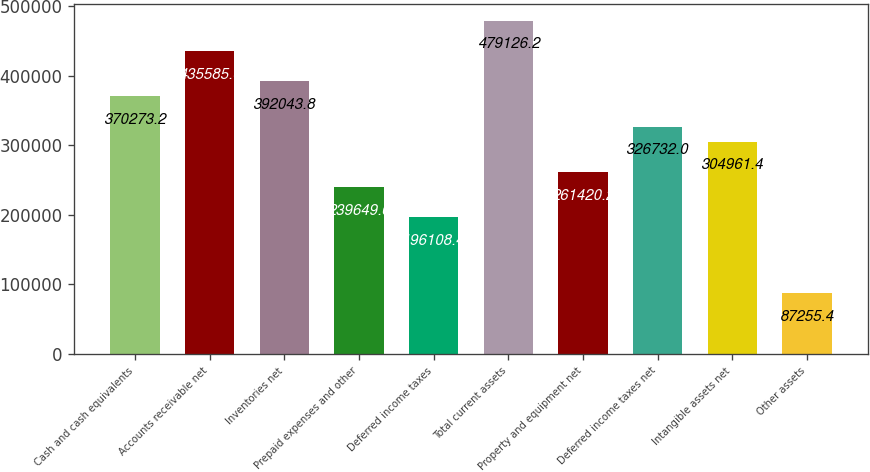<chart> <loc_0><loc_0><loc_500><loc_500><bar_chart><fcel>Cash and cash equivalents<fcel>Accounts receivable net<fcel>Inventories net<fcel>Prepaid expenses and other<fcel>Deferred income taxes<fcel>Total current assets<fcel>Property and equipment net<fcel>Deferred income taxes net<fcel>Intangible assets net<fcel>Other assets<nl><fcel>370273<fcel>435585<fcel>392044<fcel>239650<fcel>196108<fcel>479126<fcel>261420<fcel>326732<fcel>304961<fcel>87255.4<nl></chart> 